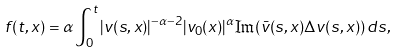Convert formula to latex. <formula><loc_0><loc_0><loc_500><loc_500>f ( t , x ) = \alpha \int _ { 0 } ^ { t } | v ( s , x ) | ^ { - \alpha - 2 } | v _ { 0 } ( x ) | ^ { \alpha } \Im ( \bar { v } ( s , x ) \Delta v ( s , x ) ) \, d s ,</formula> 